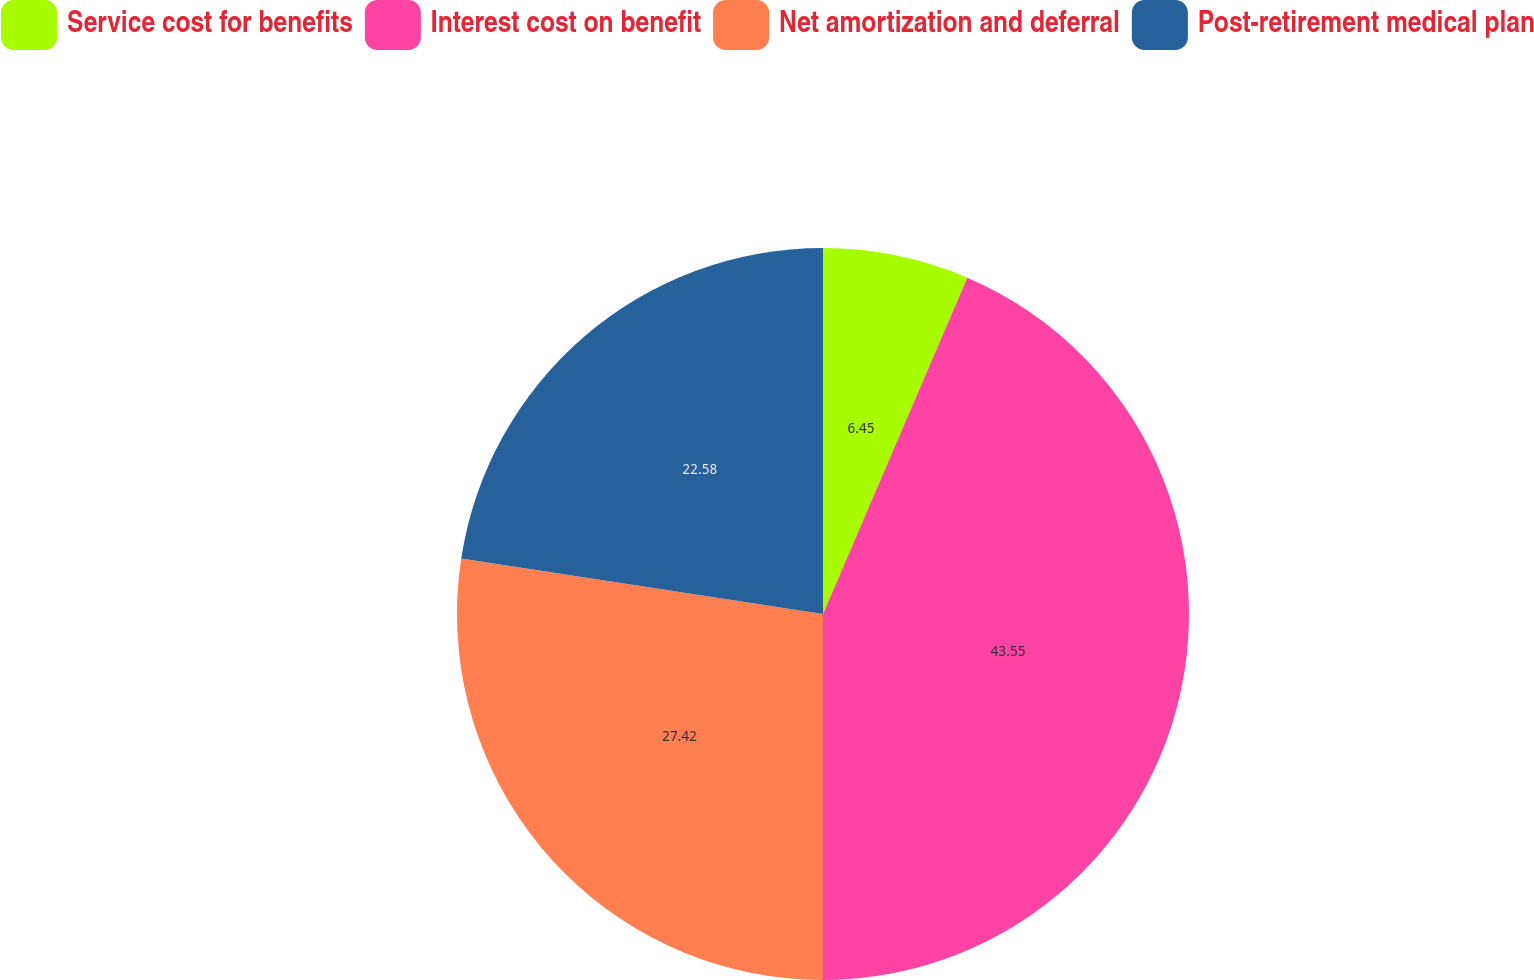<chart> <loc_0><loc_0><loc_500><loc_500><pie_chart><fcel>Service cost for benefits<fcel>Interest cost on benefit<fcel>Net amortization and deferral<fcel>Post-retirement medical plan<nl><fcel>6.45%<fcel>43.55%<fcel>27.42%<fcel>22.58%<nl></chart> 